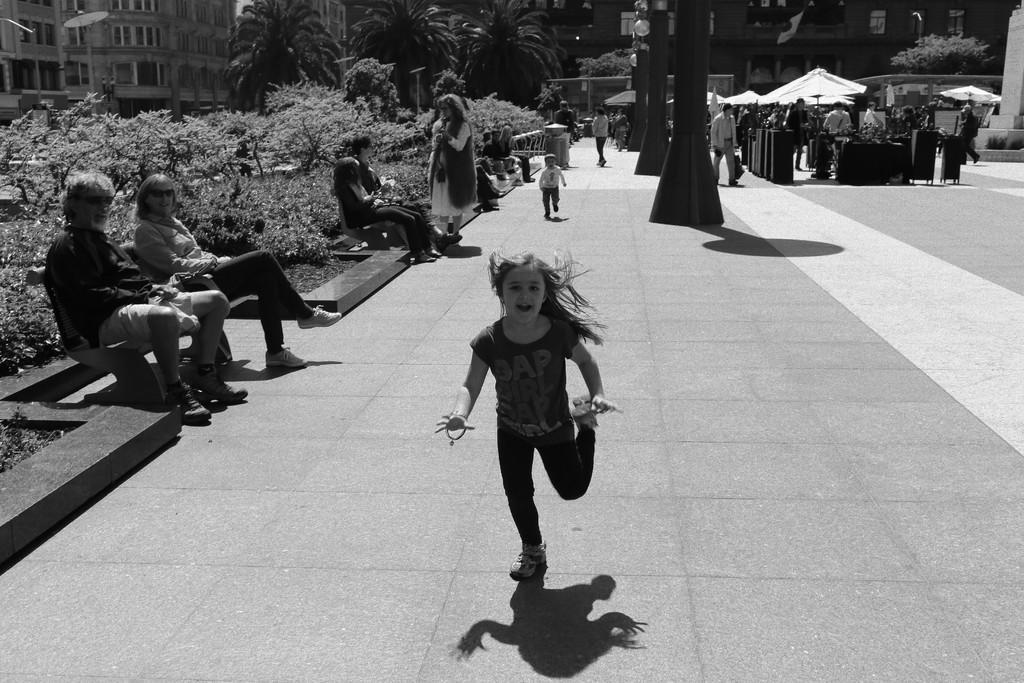Describe this image in one or two sentences. It looks like a black and white picture, we can see there are two kids running on the path. On the left side of the kids there is a person standing and other people are sitting on the benches. On the right side of the kids there are poles and some people are standing. Behind the people there are trees and buildings. 